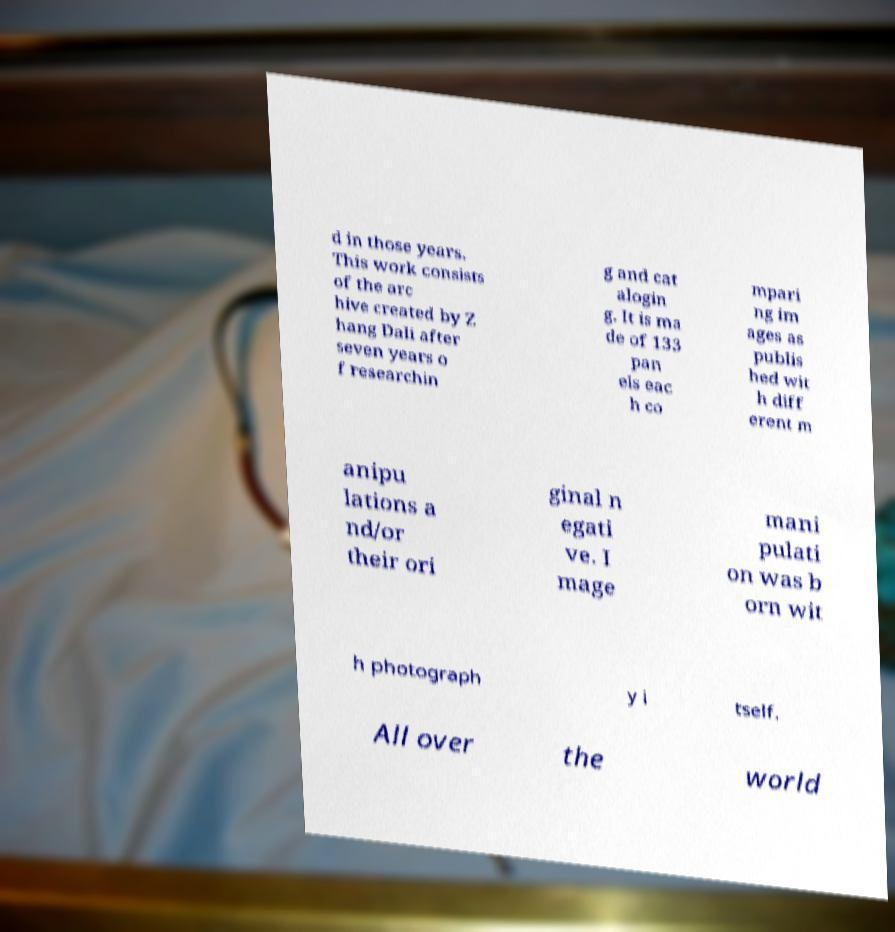What messages or text are displayed in this image? I need them in a readable, typed format. d in those years. This work consists of the arc hive created by Z hang Dali after seven years o f researchin g and cat alogin g. It is ma de of 133 pan els eac h co mpari ng im ages as publis hed wit h diff erent m anipu lations a nd/or their ori ginal n egati ve. I mage mani pulati on was b orn wit h photograph y i tself. All over the world 